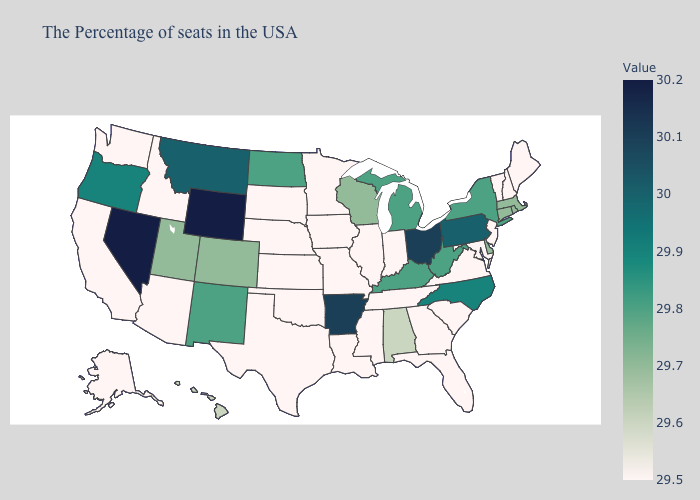Does South Dakota have the lowest value in the USA?
Concise answer only. Yes. Which states have the lowest value in the USA?
Keep it brief. Maine, New Hampshire, Vermont, New Jersey, Maryland, Virginia, South Carolina, Florida, Georgia, Indiana, Tennessee, Illinois, Mississippi, Louisiana, Missouri, Minnesota, Iowa, Kansas, Nebraska, Oklahoma, Texas, South Dakota, Arizona, Idaho, California, Washington, Alaska. Does New Jersey have the lowest value in the USA?
Be succinct. Yes. Among the states that border Nebraska , does Wyoming have the highest value?
Answer briefly. Yes. Which states have the lowest value in the USA?
Give a very brief answer. Maine, New Hampshire, Vermont, New Jersey, Maryland, Virginia, South Carolina, Florida, Georgia, Indiana, Tennessee, Illinois, Mississippi, Louisiana, Missouri, Minnesota, Iowa, Kansas, Nebraska, Oklahoma, Texas, South Dakota, Arizona, Idaho, California, Washington, Alaska. 